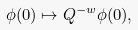<formula> <loc_0><loc_0><loc_500><loc_500>\phi ( 0 ) \mapsto Q ^ { - w } \phi ( 0 ) ,</formula> 